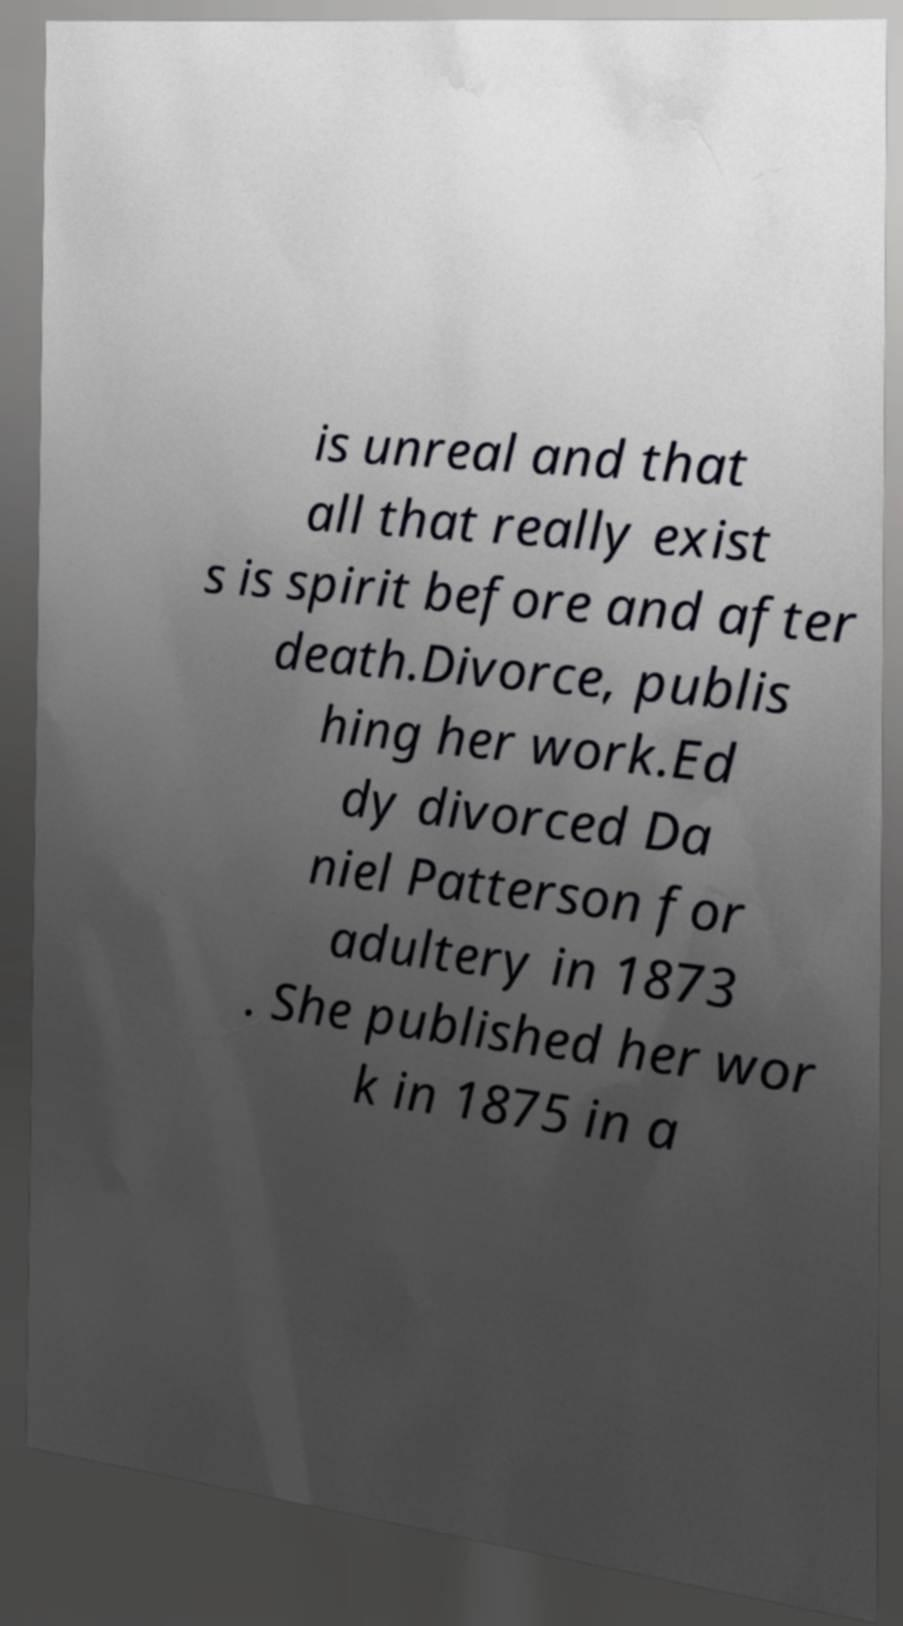Can you accurately transcribe the text from the provided image for me? is unreal and that all that really exist s is spirit before and after death.Divorce, publis hing her work.Ed dy divorced Da niel Patterson for adultery in 1873 . She published her wor k in 1875 in a 